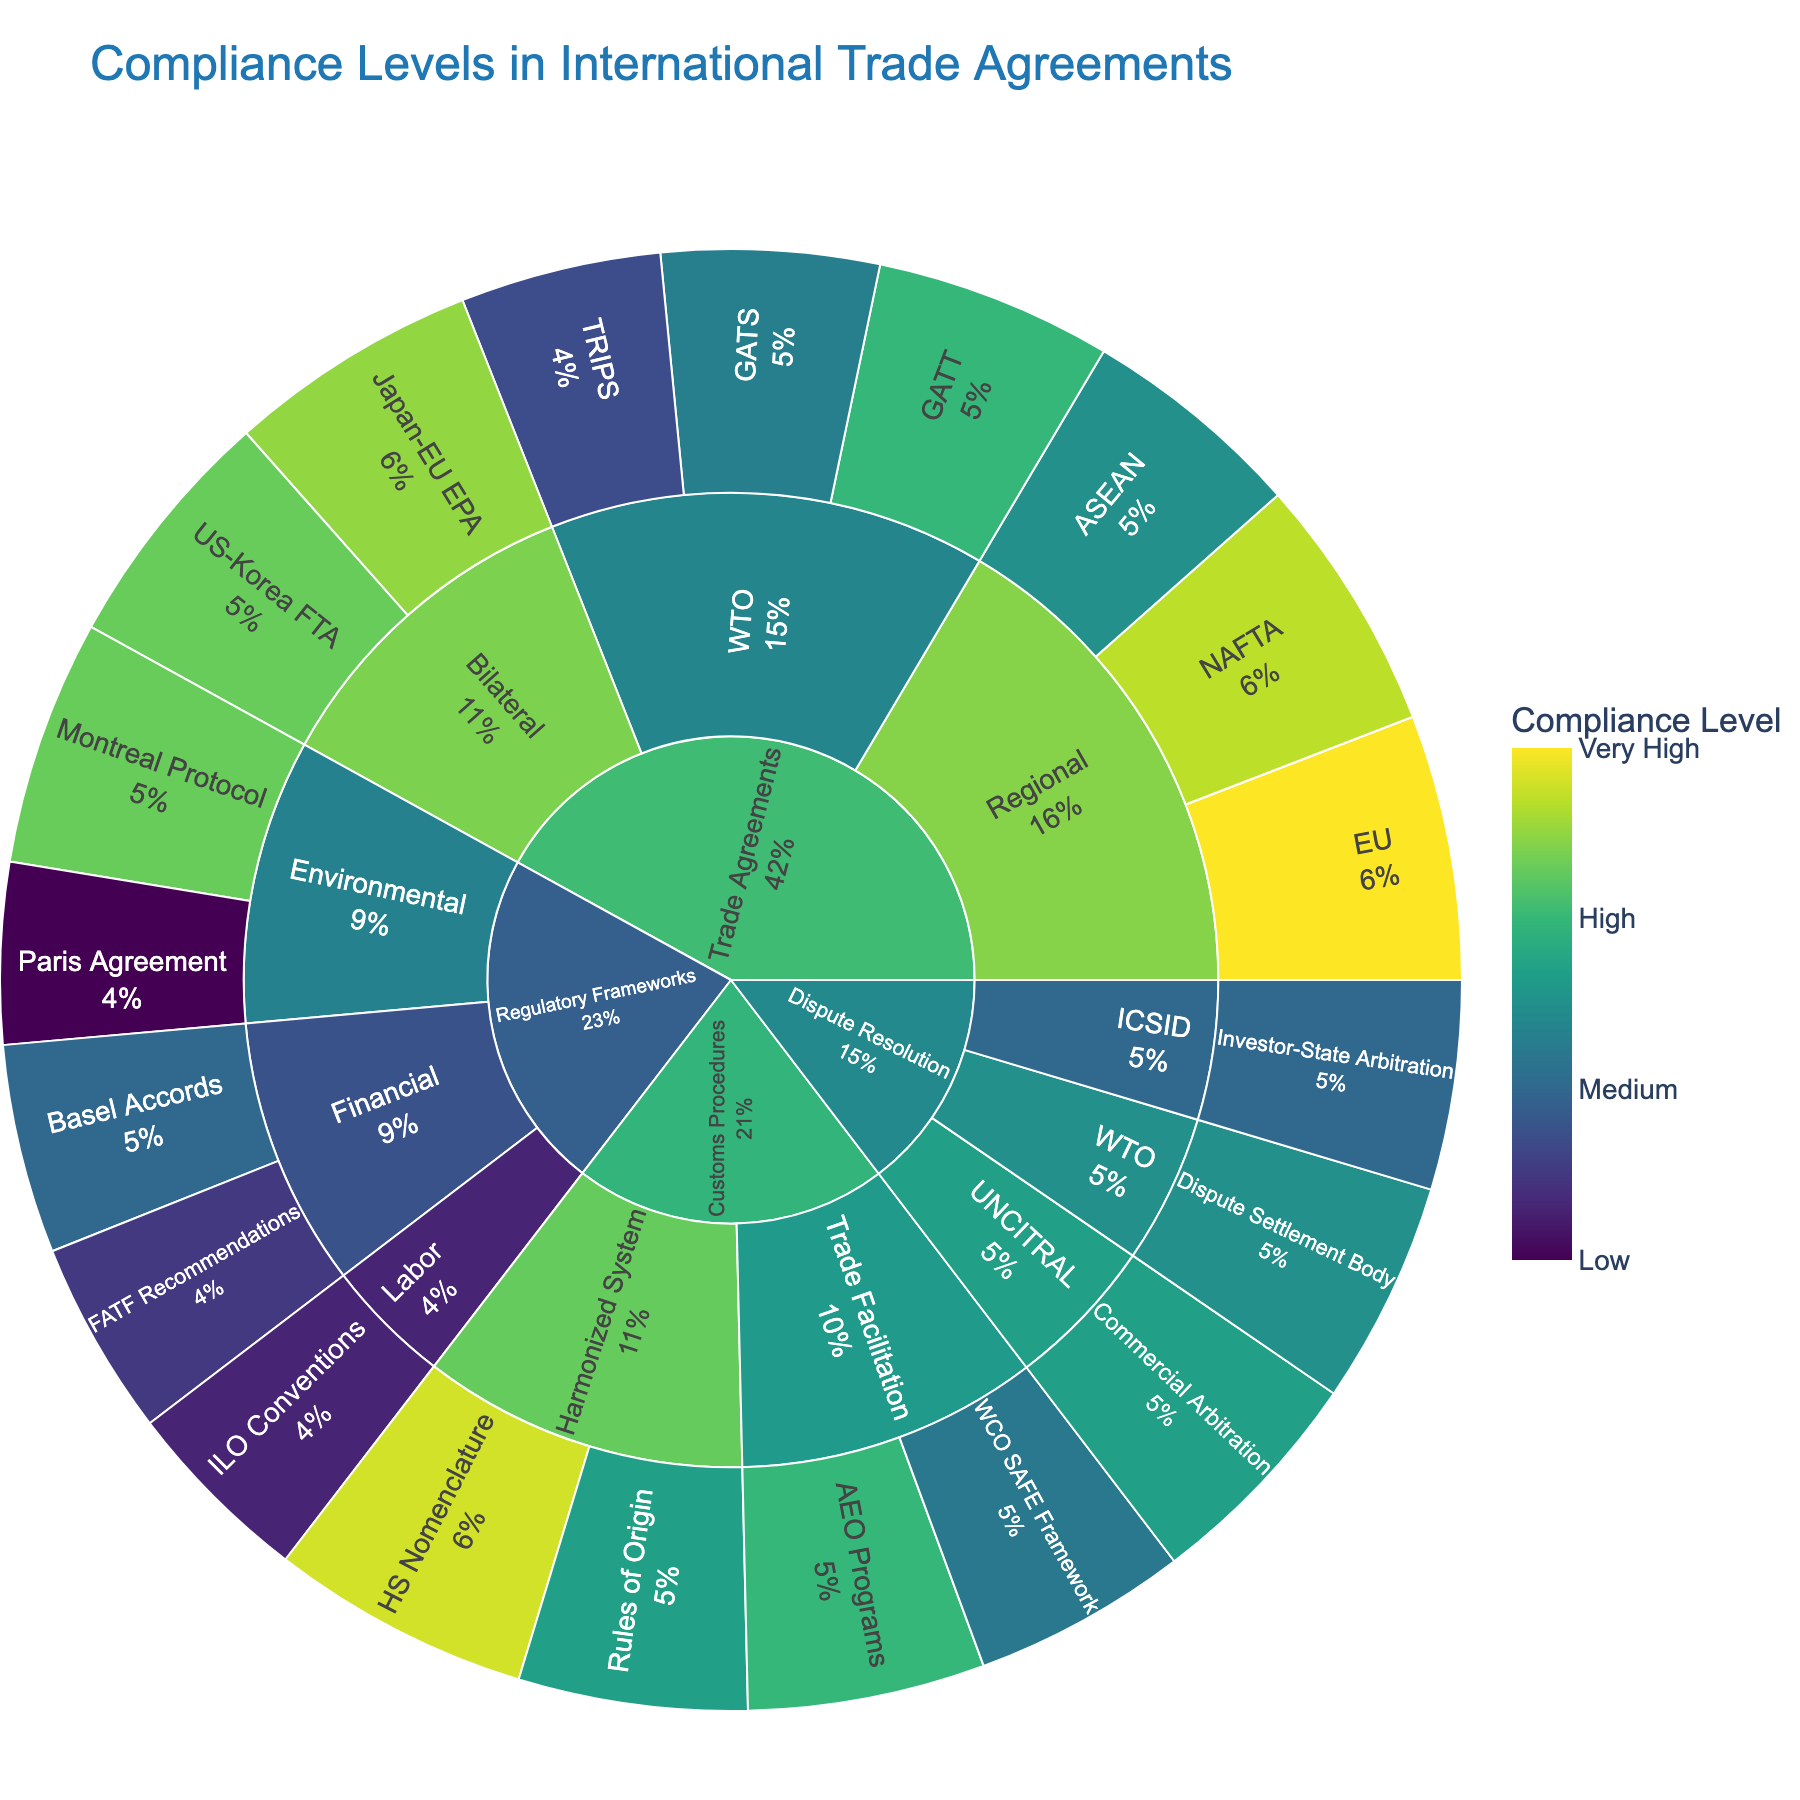What is the title of the Sunburst plot? The title of the Sunburst plot is displayed at the top of the figure.
Answer: Compliance Levels in International Trade Agreements Which category has the agreement with the highest compliance level? Look at the inner ring of the Sunburst plot for the three main categories. Find the highest compliance value displayed as a color close to the maximum on the color scale, and trace it back to its category.
Answer: Customs Procedures Which agreement has the lowest compliance level under the Trade Agreements category? Within the Trade Agreements category, identify all agreements' compliance levels and pick the lowest value.
Answer: TRIPS Compare the compliance levels of the Paris Agreement and the Montreal Protocol. Which one is higher? Locate both agreements under the Regulatory Frameworks -> Environmental subcategory and compare their compliance levels.
Answer: Montreal Protocol What is the compliance level of the US-Korea FTA? Look under Trade Agreements -> Bilateral for the US-Korea FTA.
Answer: 88 Summarize the compliance levels across the WTO subcategory under Trade Agreements. What is their average compliance level? Find the compliance levels for GATT (85), GATS (78), and TRIPS (72). Calculate the average: (85 + 78 + 72) / 3.
Answer: 78.33 Which subcategory under Regulatory Frameworks has the lowest compliance level, and what is it? Identify and compare compliance levels for all subcategories under Regulatory Frameworks: Financial (Basel Accords, FATF Recommendations), Environmental (Paris Agreement, Montreal Protocol), and Labor (ILO Conventions).
Answer: Labor, 68 What is the compliance difference between NAFTA and the EU agreement under the Regional subcategory of Trade Agreements? Look at the compliance levels of NAFTA (92) and EU (95) under Trade Agreements -> Regional and calculate the difference: 95 - 92.
Answer: 3 Under Customs Procedures, which agreement within Trade Facilitation has a higher compliance, WCO SAFE Framework or AEO Programs? Compare the compliance levels of WCO SAFE Framework (77) and AEO Programs (85) within the Trade Facilitation subcategory.
Answer: AEO Programs How does the compliance level of the Dispute Settlement Body compare to that of the Investor-State Arbitration in the Dispute Resolution category? Look under Dispute Resolution for both Dispute Settlement Body and Investor-State Arbitration and compare their compliance levels: DSB (80) and ICSID.
Answer: Dispute Settlement Body has higher compliance 